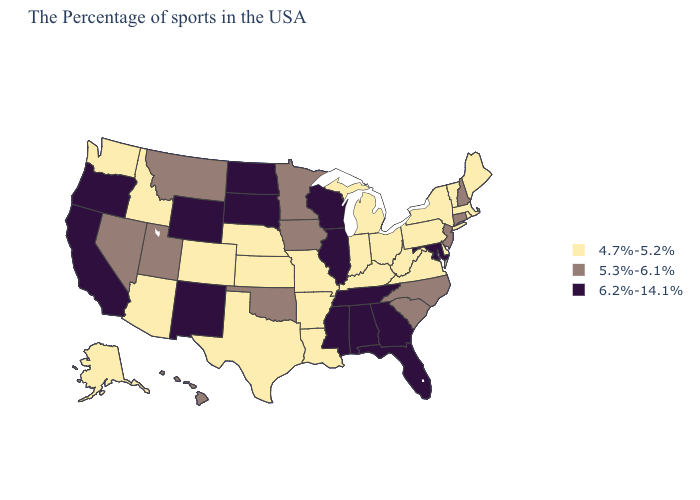Which states hav the highest value in the Northeast?
Short answer required. New Hampshire, Connecticut, New Jersey. Name the states that have a value in the range 4.7%-5.2%?
Write a very short answer. Maine, Massachusetts, Rhode Island, Vermont, New York, Delaware, Pennsylvania, Virginia, West Virginia, Ohio, Michigan, Kentucky, Indiana, Louisiana, Missouri, Arkansas, Kansas, Nebraska, Texas, Colorado, Arizona, Idaho, Washington, Alaska. Does the map have missing data?
Be succinct. No. Which states have the lowest value in the USA?
Short answer required. Maine, Massachusetts, Rhode Island, Vermont, New York, Delaware, Pennsylvania, Virginia, West Virginia, Ohio, Michigan, Kentucky, Indiana, Louisiana, Missouri, Arkansas, Kansas, Nebraska, Texas, Colorado, Arizona, Idaho, Washington, Alaska. Name the states that have a value in the range 4.7%-5.2%?
Short answer required. Maine, Massachusetts, Rhode Island, Vermont, New York, Delaware, Pennsylvania, Virginia, West Virginia, Ohio, Michigan, Kentucky, Indiana, Louisiana, Missouri, Arkansas, Kansas, Nebraska, Texas, Colorado, Arizona, Idaho, Washington, Alaska. What is the value of Montana?
Be succinct. 5.3%-6.1%. Does Illinois have the lowest value in the USA?
Be succinct. No. What is the value of Texas?
Keep it brief. 4.7%-5.2%. Among the states that border Iowa , which have the lowest value?
Short answer required. Missouri, Nebraska. Among the states that border New Hampshire , which have the highest value?
Give a very brief answer. Maine, Massachusetts, Vermont. Name the states that have a value in the range 4.7%-5.2%?
Be succinct. Maine, Massachusetts, Rhode Island, Vermont, New York, Delaware, Pennsylvania, Virginia, West Virginia, Ohio, Michigan, Kentucky, Indiana, Louisiana, Missouri, Arkansas, Kansas, Nebraska, Texas, Colorado, Arizona, Idaho, Washington, Alaska. Which states have the lowest value in the Northeast?
Quick response, please. Maine, Massachusetts, Rhode Island, Vermont, New York, Pennsylvania. What is the lowest value in the South?
Quick response, please. 4.7%-5.2%. What is the highest value in the USA?
Be succinct. 6.2%-14.1%. 